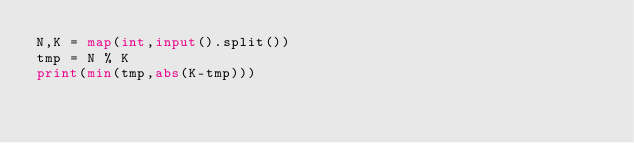<code> <loc_0><loc_0><loc_500><loc_500><_Python_>N,K = map(int,input().split())
tmp = N % K
print(min(tmp,abs(K-tmp)))</code> 